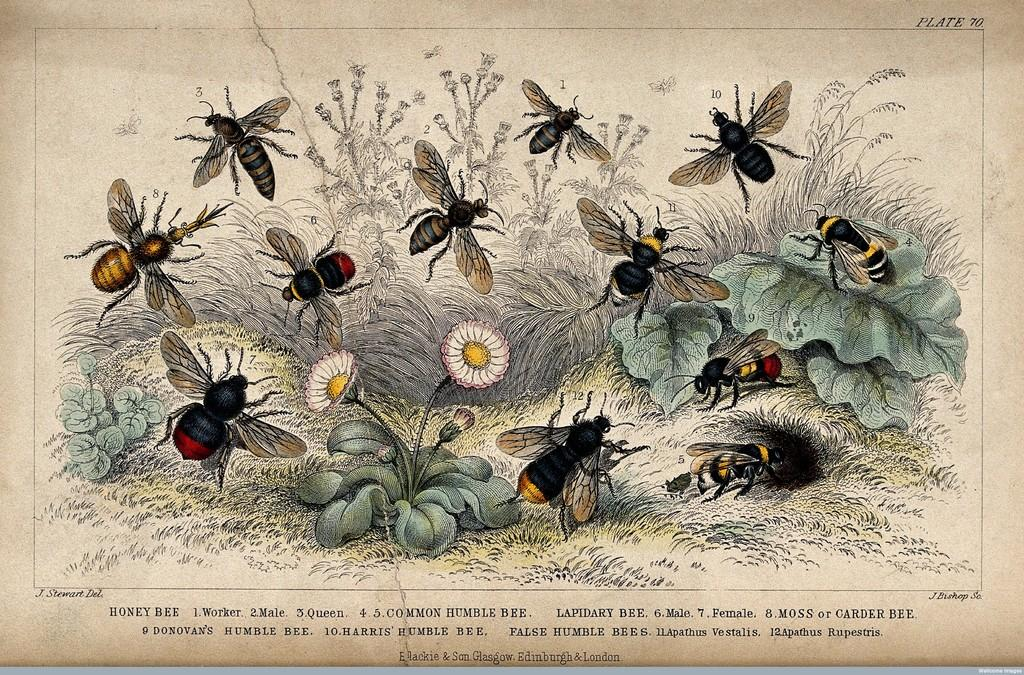What type of living organisms can be seen in the image? Insects can be seen in the image. What type of plants are in the image? There are flowers and other plants in the image. What is the purpose of the paper with text in the image? The purpose of the paper with text is not clear from the image alone. Can you describe the setting where the insects and plants are located? The setting is not clearly defined, but it appears to be a natural environment with insects, flowers, and other plants. Where are the scissors kept in the image? There are no scissors present in the image. What type of shoe can be seen in the image? There is no shoe present in the image. 